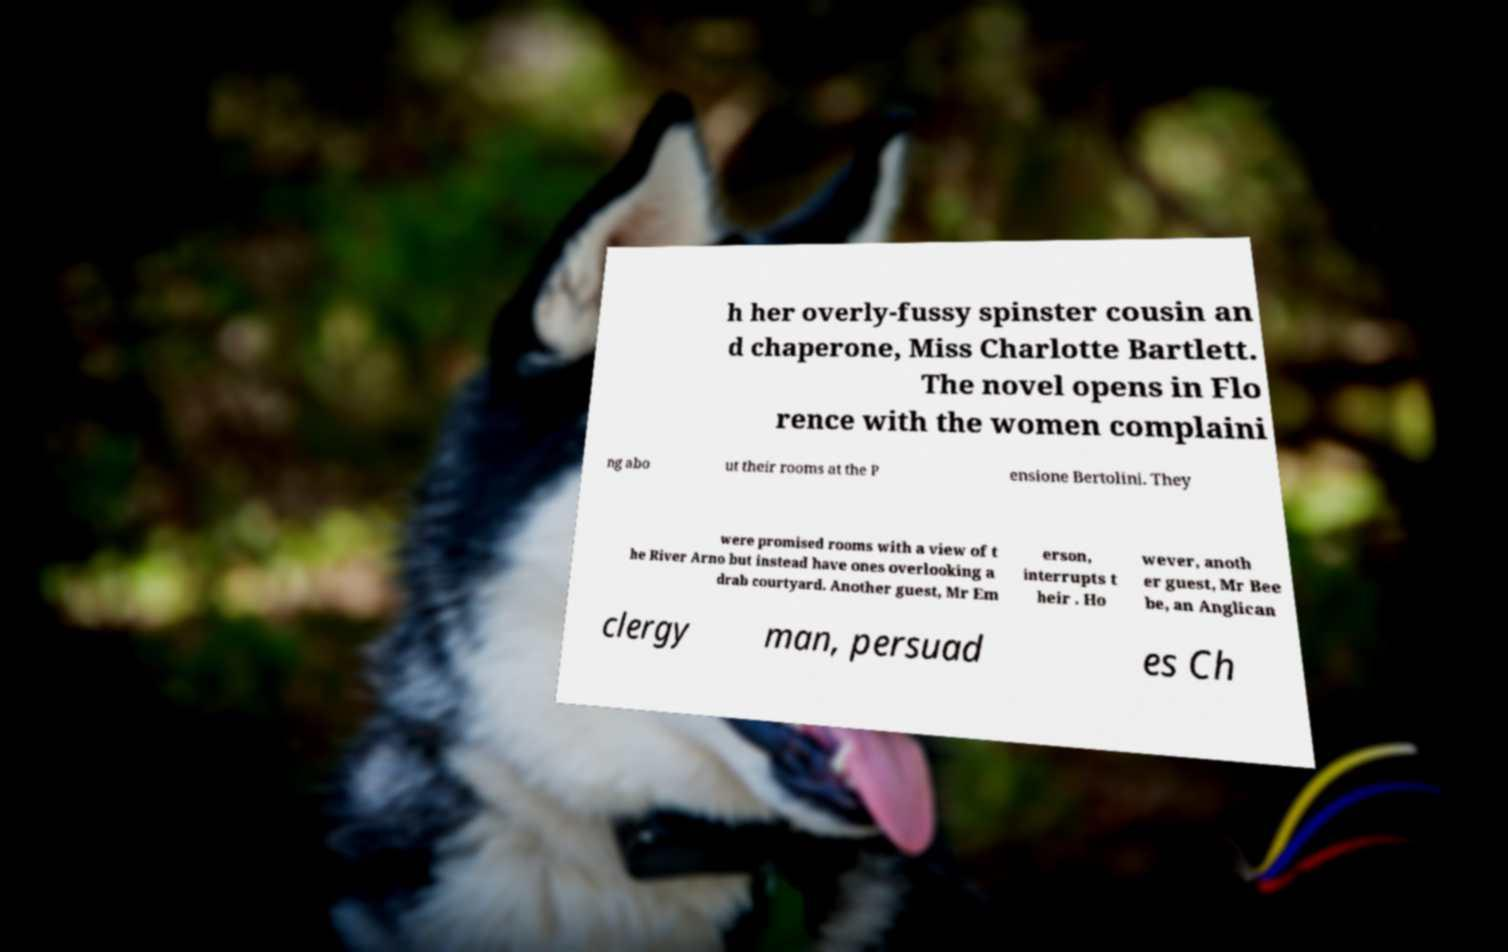I need the written content from this picture converted into text. Can you do that? h her overly-fussy spinster cousin an d chaperone, Miss Charlotte Bartlett. The novel opens in Flo rence with the women complaini ng abo ut their rooms at the P ensione Bertolini. They were promised rooms with a view of t he River Arno but instead have ones overlooking a drab courtyard. Another guest, Mr Em erson, interrupts t heir . Ho wever, anoth er guest, Mr Bee be, an Anglican clergy man, persuad es Ch 